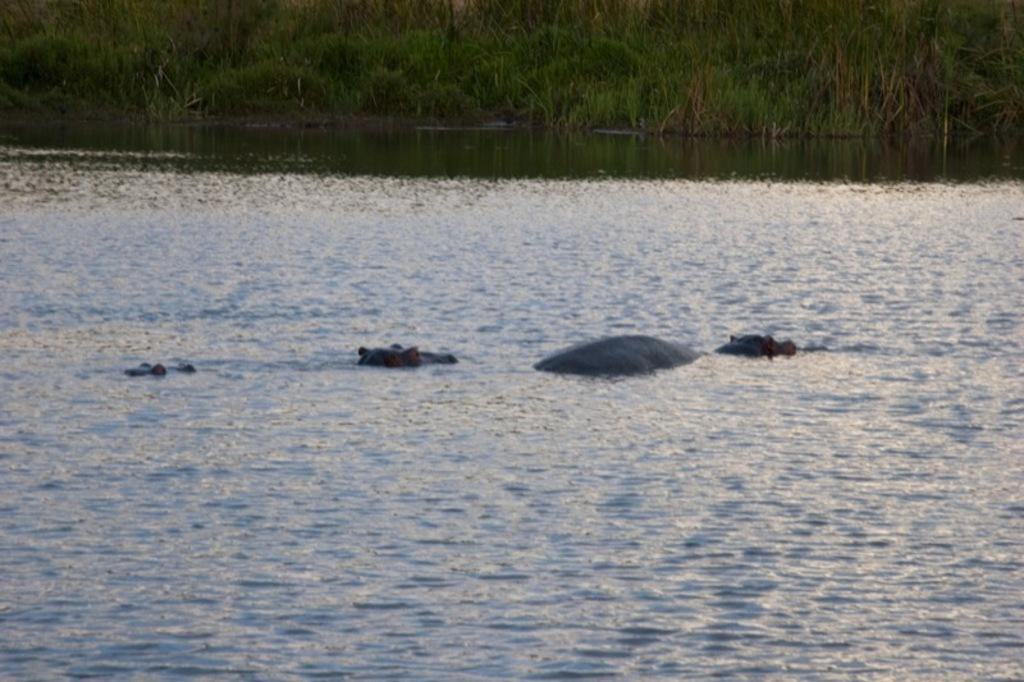What type of animals can be seen in the image? There are animals in the water. What can be seen in the background of the image? There is green grass visible in the background of the image. What type of book is being read in the image? There is no book present in the image; it features animals in the water and green grass. 